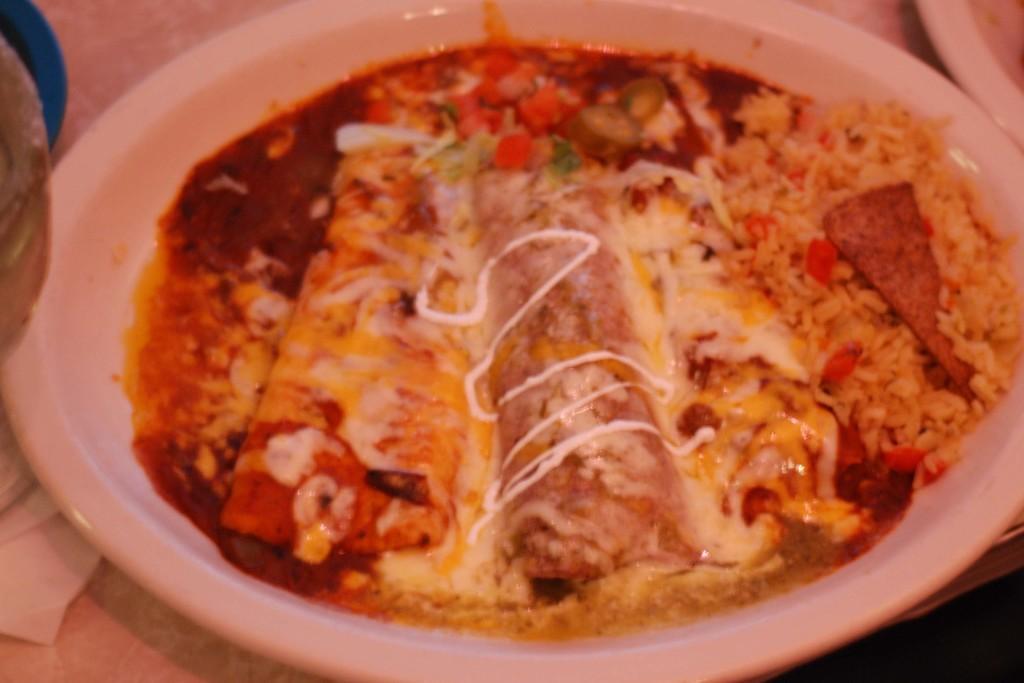In one or two sentences, can you explain what this image depicts? In this image we can see a plate filled with food item. 